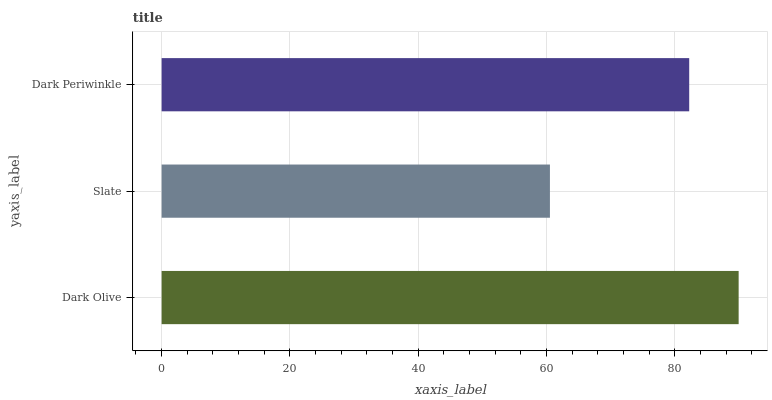Is Slate the minimum?
Answer yes or no. Yes. Is Dark Olive the maximum?
Answer yes or no. Yes. Is Dark Periwinkle the minimum?
Answer yes or no. No. Is Dark Periwinkle the maximum?
Answer yes or no. No. Is Dark Periwinkle greater than Slate?
Answer yes or no. Yes. Is Slate less than Dark Periwinkle?
Answer yes or no. Yes. Is Slate greater than Dark Periwinkle?
Answer yes or no. No. Is Dark Periwinkle less than Slate?
Answer yes or no. No. Is Dark Periwinkle the high median?
Answer yes or no. Yes. Is Dark Periwinkle the low median?
Answer yes or no. Yes. Is Dark Olive the high median?
Answer yes or no. No. Is Dark Olive the low median?
Answer yes or no. No. 